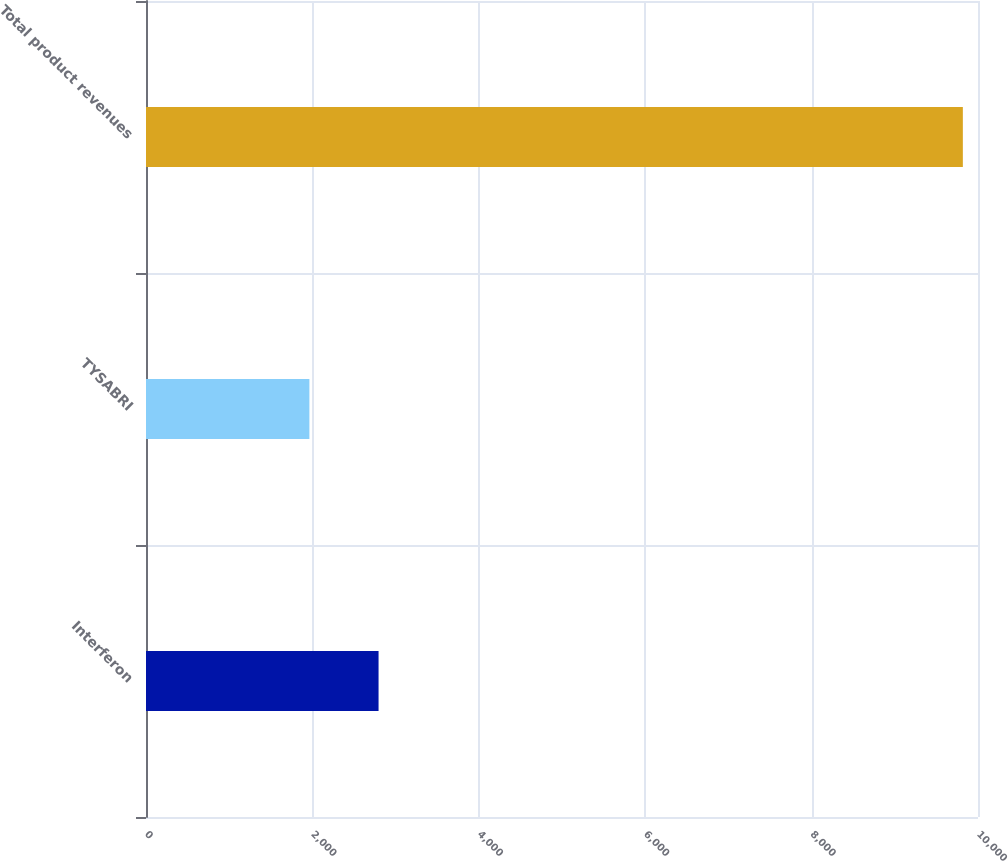<chart> <loc_0><loc_0><loc_500><loc_500><bar_chart><fcel>Interferon<fcel>TYSABRI<fcel>Total product revenues<nl><fcel>2795.2<fcel>1963.8<fcel>9817.9<nl></chart> 